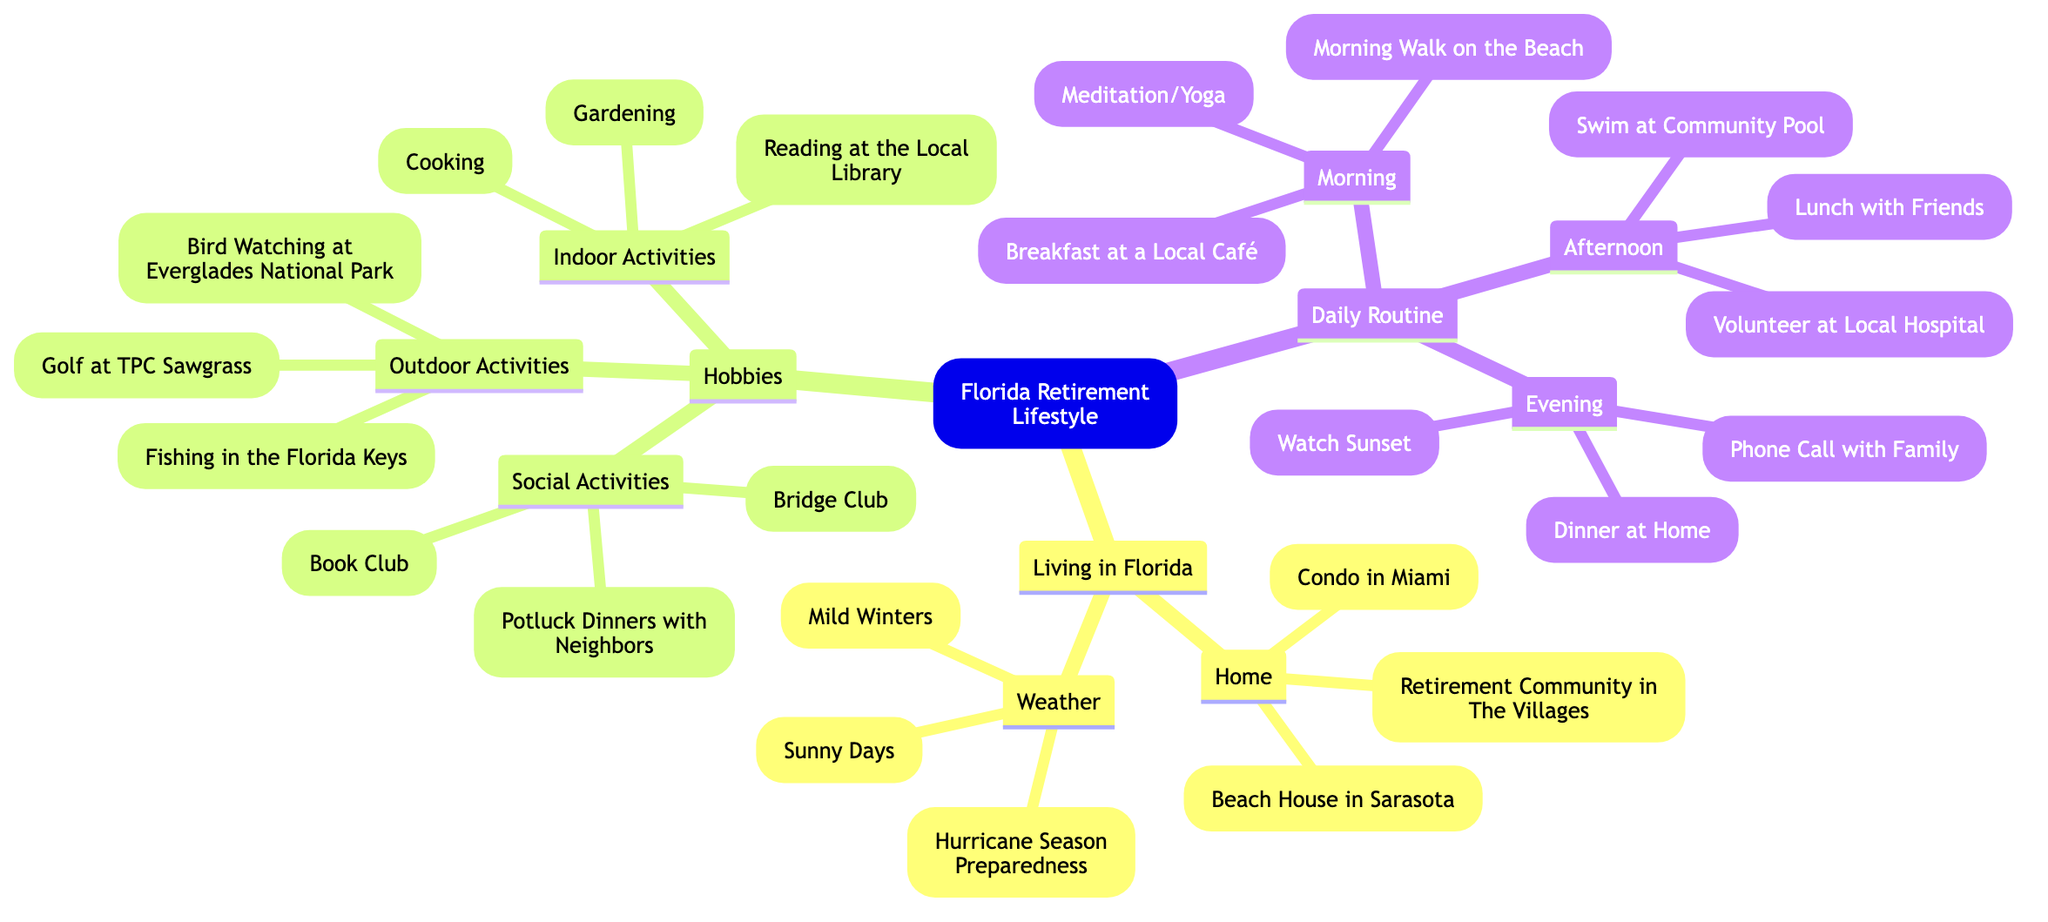What are the three types of living arrangements listed under Living in Florida? The diagram lists three types of living arrangements under the "Home" category: "Condo in Miami," "Retirement Community in The Villages," and "Beach House in Sarasota."
Answer: Condo in Miami, Retirement Community in The Villages, Beach House in Sarasota How many outdoor activities are included in the Hobbies section? The diagram lists three outdoor activities: "Golf at TPC Sawgrass," "Fishing in the Florida Keys," and "Bird Watching at Everglades National Park." Thus, there are three outdoor activities in total.
Answer: 3 What activity is common during both the Morning and Afternoon sections of the Daily Routine? In the Morning section, "Breakfast at a Local Café" occurs, and in the Afternoon section, there is "Lunch with Friends." Both are meal times, and potentially, eating is a common activity. However, strictly speaking, these are two different activities. Since there's no identical activity listed, the answer should reflect that correctly.
Answer: None Which weather condition is specifically related to the preparation for emergencies? Under "Weather," "Hurricane Season Preparedness" specifically relates to emergency preparations. It indicates that individuals need to be ready for storms commonly associated with seasonal changes in Florida.
Answer: Hurricane Season Preparedness What is the first activity mentioned under the Morning routine? The first activity listed under the "Morning" routine is "Meditation/Yoga." This can be found immediately as the first item in that section of the diagram.
Answer: Meditation/Yoga Which social activity involves neighborly gatherings according to the Hobbies section? The "Potluck Dinners with Neighbors" is the social activity that involves gatherings among neighbors. It emphasizes a communal and social aspect enjoyed in their lifestyle.
Answer: Potluck Dinners with Neighbors How many parts are included in the Daily Routine? The "Daily Routine" section is divided into three parts: "Morning," "Afternoon," and "Evening." This can be tallied directly by counting the main headings in that section.
Answer: 3 What two activities are listed in the Evening section of the Daily Routine? The Evening section lists "Dinner at Home" and "Watch Sunset," along with "Phone Call with Family." Therefore, the answer requires selecting two of these listed activities.
Answer: Dinner at Home, Watch Sunset Which hobby from the Indoor Activities category could be related to creativity? "Cooking" from the Indoor Activities category can be considered a creative hobby as it involves preparing and combining different ingredients to create dishes.
Answer: Cooking 